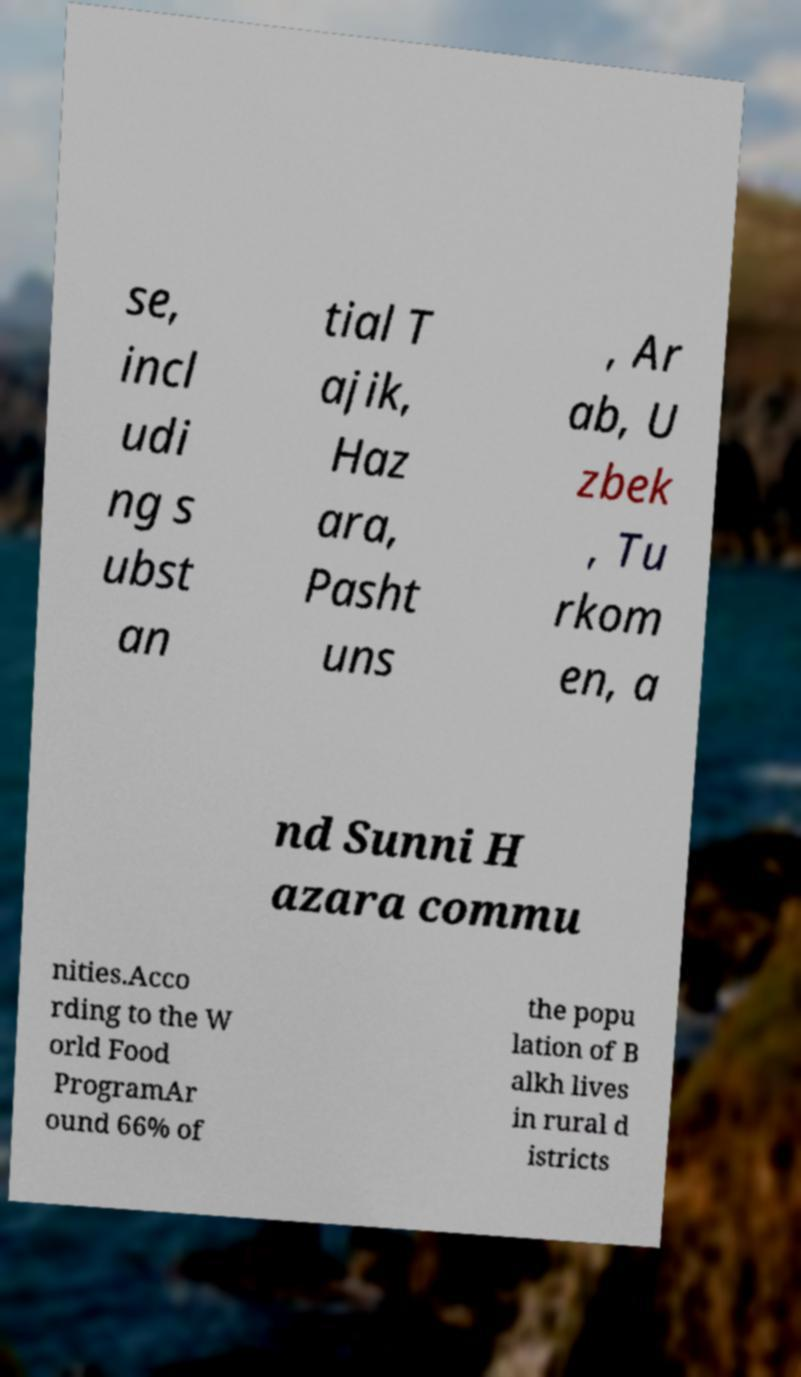Please identify and transcribe the text found in this image. se, incl udi ng s ubst an tial T ajik, Haz ara, Pasht uns , Ar ab, U zbek , Tu rkom en, a nd Sunni H azara commu nities.Acco rding to the W orld Food ProgramAr ound 66% of the popu lation of B alkh lives in rural d istricts 